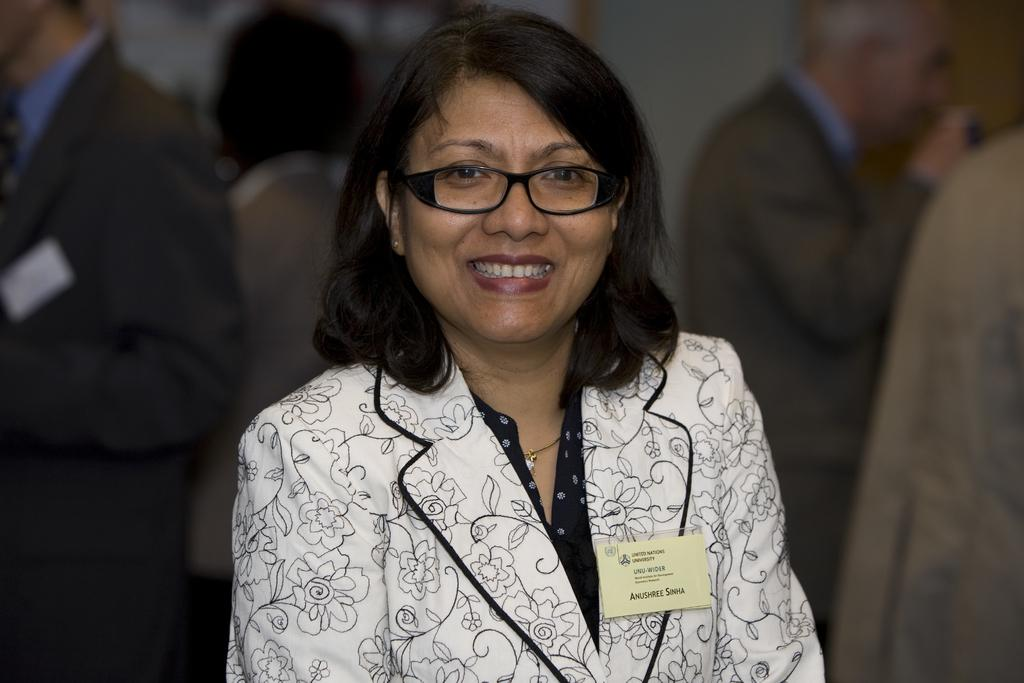Who is the main subject in the image? There is a lady in the center of the image. What is the lady wearing? The lady is wearing a coat and spectacles. What is the lady's facial expression? The lady is smiling. What can be seen in the background of the image? There is a wall and people standing in the background of the image. Where is the hen located in the image? There is no hen present in the image. What color is the lady's heart in the image? The lady's heart is not visible in the image, as it is an internal organ and not something that can be seen. 